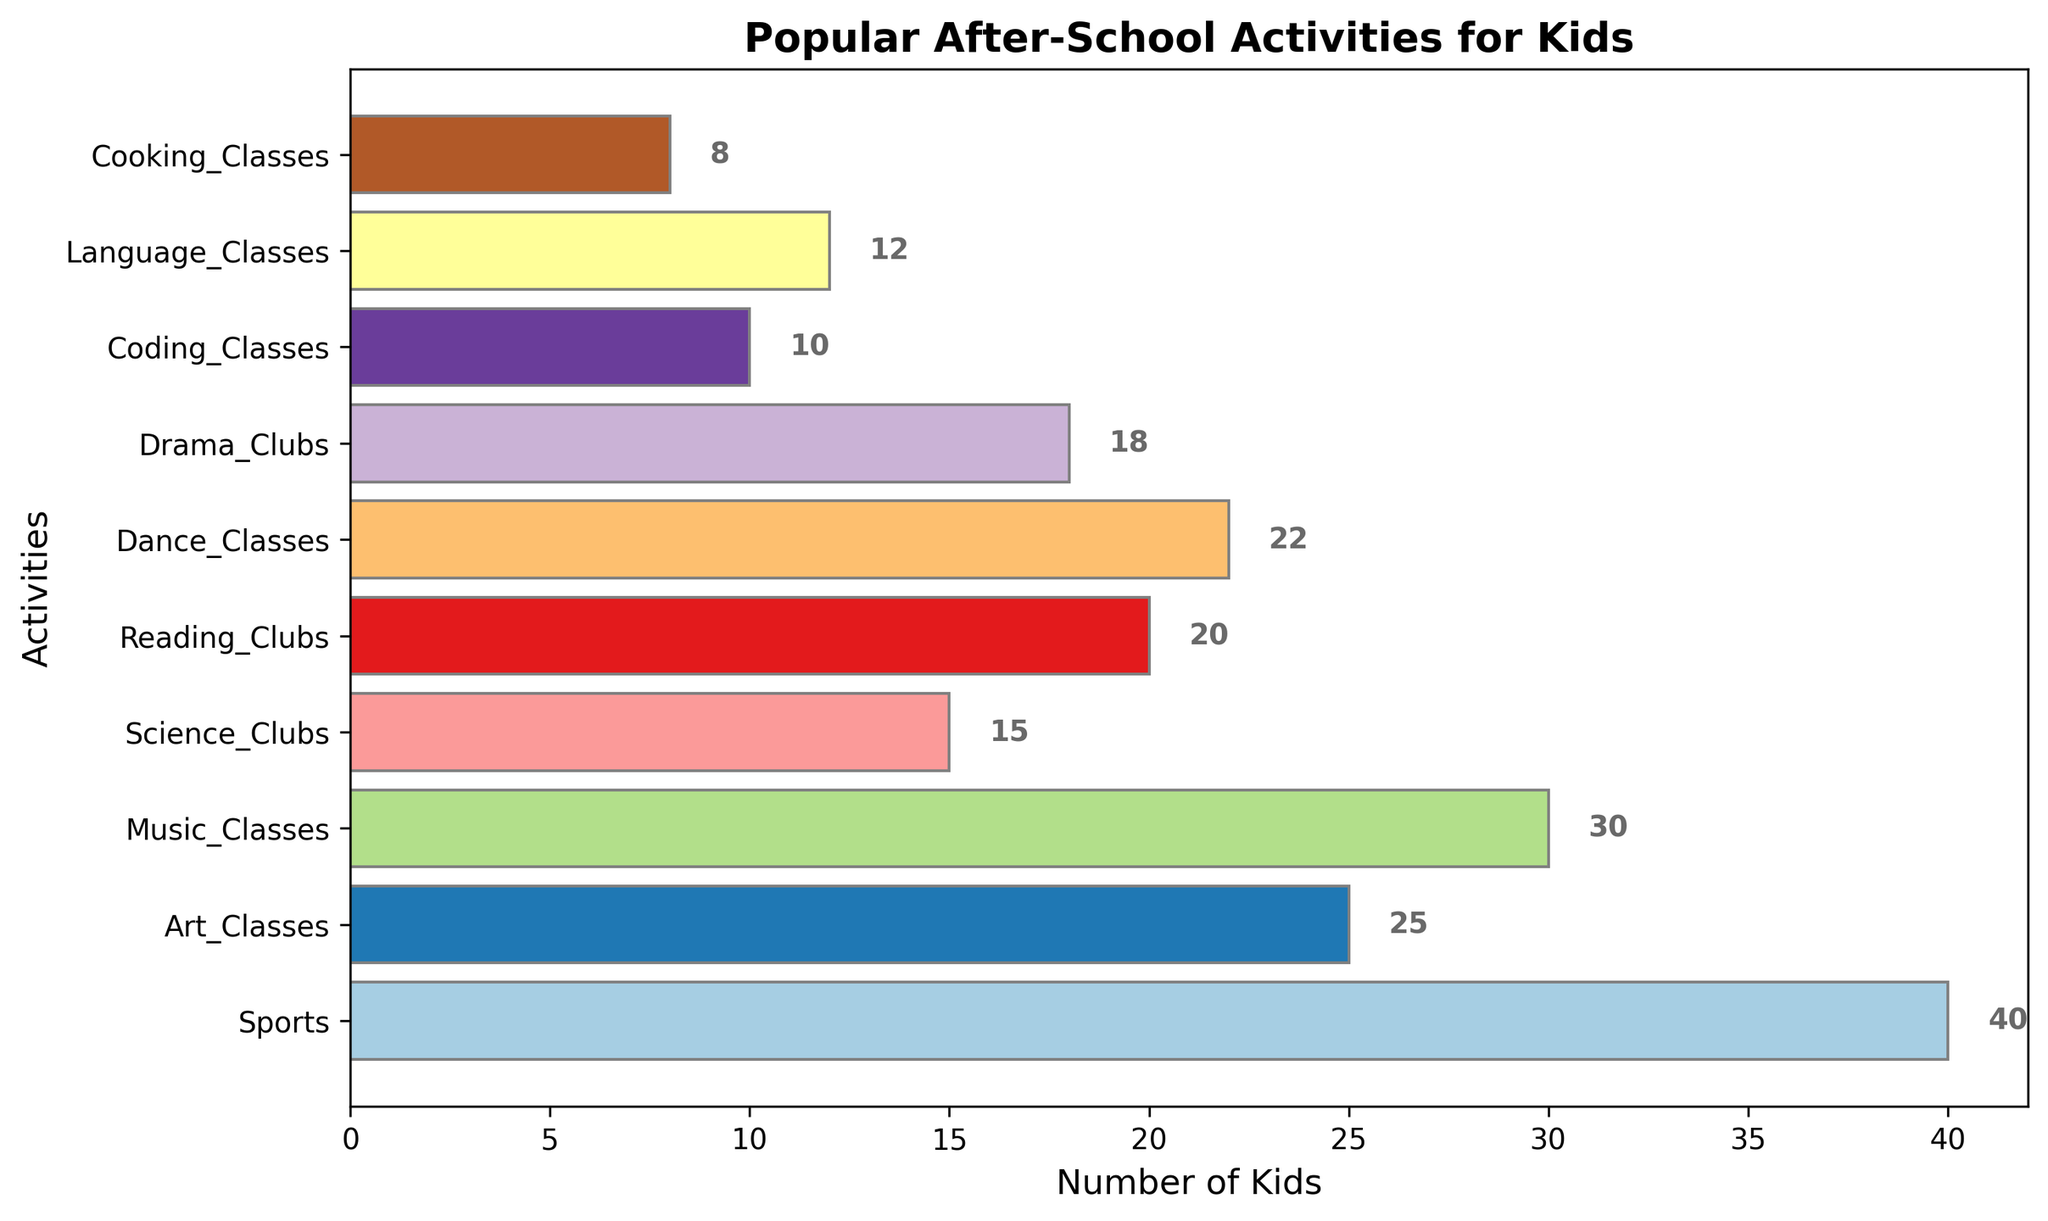Which after-school activity is the most popular among kids? Locate the bar with the greatest length. 'Sports' has the highest bar at 40 kids.
Answer: Sports Which activity has fewer kids, Music Classes or Dance Classes? Compare the lengths of the bars for 'Music Classes' and 'Dance Classes'. 'Music Classes' has 30 kids, which is greater than the 22 kids in 'Dance Classes'.
Answer: Dance Classes How many more kids participate in Sports compared to Coding Classes? Subtract the number of kids in 'Coding Classes' from the number of kids in 'Sports'. 40 (Sports) - 10 (Coding Classes) = 30.
Answer: 30 If we combine the number of kids in Art Classes and Science Clubs, how many kids are participating in these two activities together? Add the number of kids in 'Art Classes' and 'Science Clubs'. 25 (Art Classes) + 15 (Science Clubs) = 40.
Answer: 40 Which activity has the least number of kids participating? Locate the shortest bar on the chart. 'Cooking Classes' has the shortest bar with 8 kids.
Answer: Cooking Classes How does the number of kids in Reading Clubs compare to those in Drama Clubs? Compare the lengths of the bars for 'Reading Clubs' and 'Drama Clubs'. 'Reading Clubs' has 20 kids and 'Drama Clubs' has 18 kids. So, Reading Clubs has more.
Answer: Reading Clubs What is the total number of kids participating in all the activities combined? Sum the number of kids participating in all activities: 40 (Sports) + 25 (Art Classes) + 30 (Music Classes) + 15 (Science Clubs) + 20 (Reading Clubs) + 22 (Dance Classes) + 18 (Drama Clubs) + 10 (Coding Classes) + 12 (Language Classes) + 8 (Cooking Classes) = 200.
Answer: 200 If we group Drama Clubs and Dance Classes together, how many kids do they have in total? Add the number of kids in 'Drama Clubs' and 'Dance Classes'. 18 (Drama Clubs) + 22 (Dance Classes) = 40.
Answer: 40 Which two activities have the closest number of kids participating? Compare consecutive bar lengths to find the closest numbers. 'Drama Clubs' with 18 kids and 'Language Classes' with 12 kids have a difference of 6, which appears smaller compared to others.
Answer: Drama Clubs and Language Classes What is the average number of kids across all activities? Divide the total number of kids by the number of activities. The total number of kids is 200 and there are 10 activities. 200 / 10 = 20.
Answer: 20 